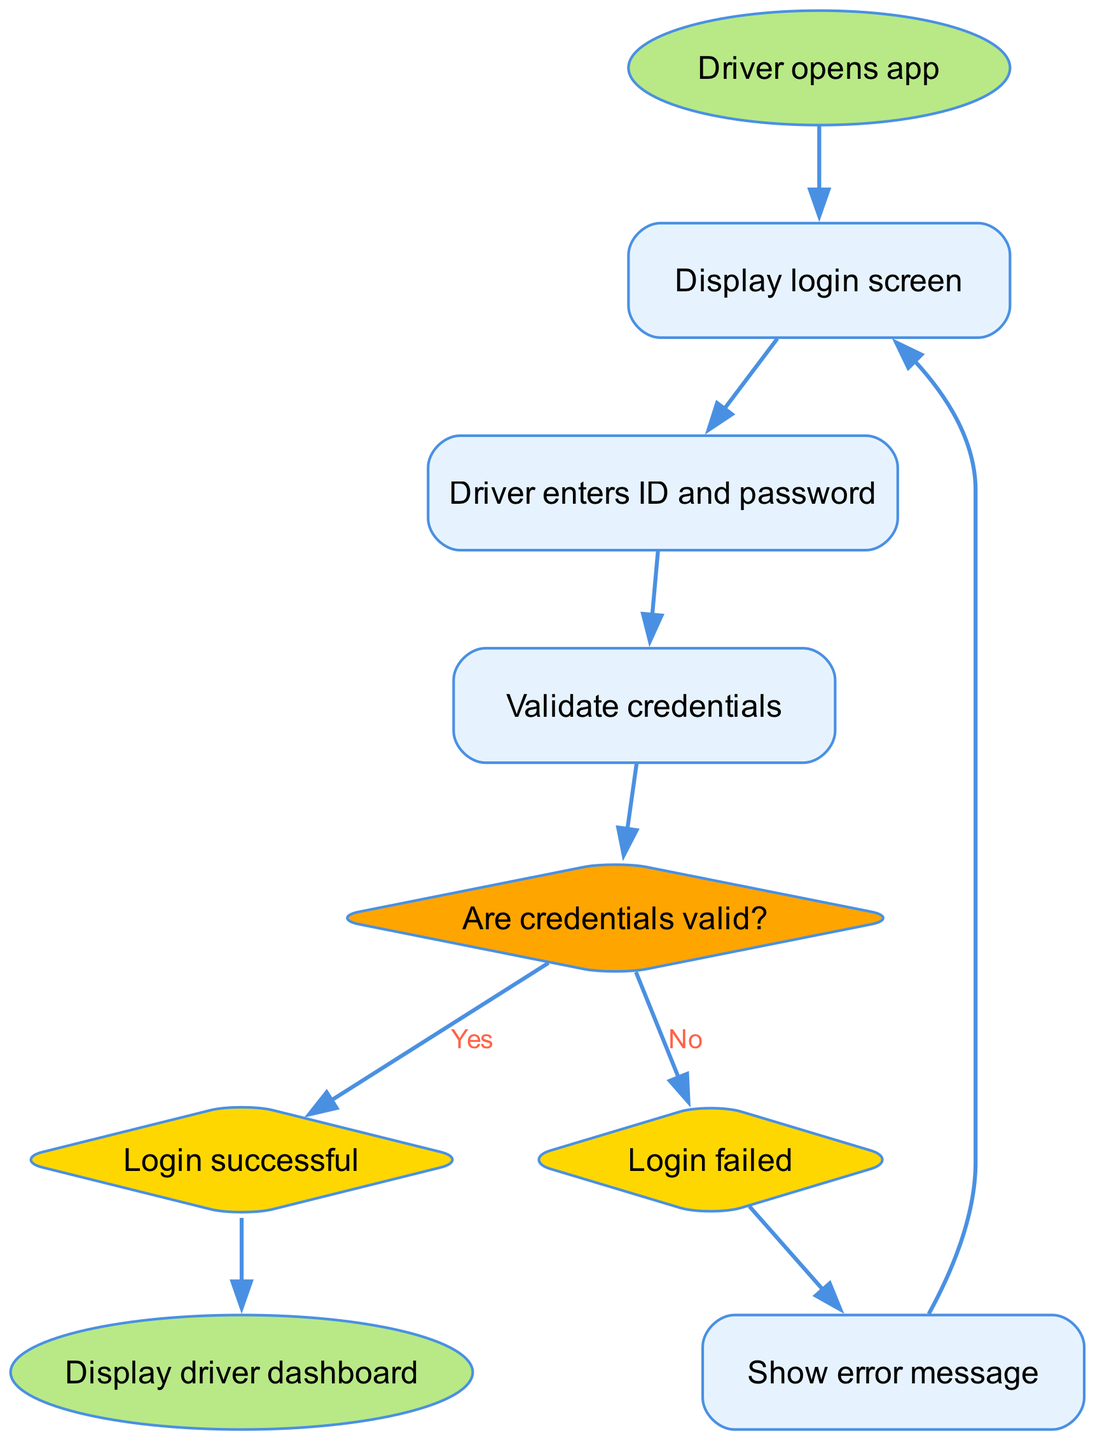What is the first action taken by the driver? The diagram indicates that the driver opens the app as the first action, as represented by the "start" node.
Answer: Driver opens app How many nodes are in the diagram? By counting the nodes listed in the data, there are a total of 9 distinct nodes present in the flowchart.
Answer: 9 What happens after the driver enters ID and password? The next step depicted in the flowchart after entering credentials is the validation of those credentials, as seen in the "validate_credentials" node.
Answer: Validate credentials What are the two outcomes when checking the validity of credentials? The diagram shows that after checking valid credentials, the two possible outcomes are "Login successful" or "Login failed," leading to different paths in the workflow.
Answer: Login successful, Login failed If the login fails, what message is shown to the driver? According to the flowchart, if the login is unsuccessful, the system displays an error message before returning to the login screen.
Answer: Show error message What decision is made after validating credentials? After the validation process, a decision point occurs where it is determined if the credentials are valid, leading to either a successful login or failure.
Answer: Are credentials valid? What shape represents the decision-making process in this diagram? The diamond shape in flowcharts is typically used to depict decision points, which in this case is used for checking the validity of credentials.
Answer: Diamond Which node leads to the driver dashboard? Upon successful login, the flowchart indicates that the next node to be displayed is the "Display driver dashboard" node, which follows the "Login successful" node.
Answer: Display driver dashboard What color represents the successful login state? In the diagram, the "Login successful" state is represented in a diamond shape, filled with a gold color, indicating it as a decision point.
Answer: Gold 